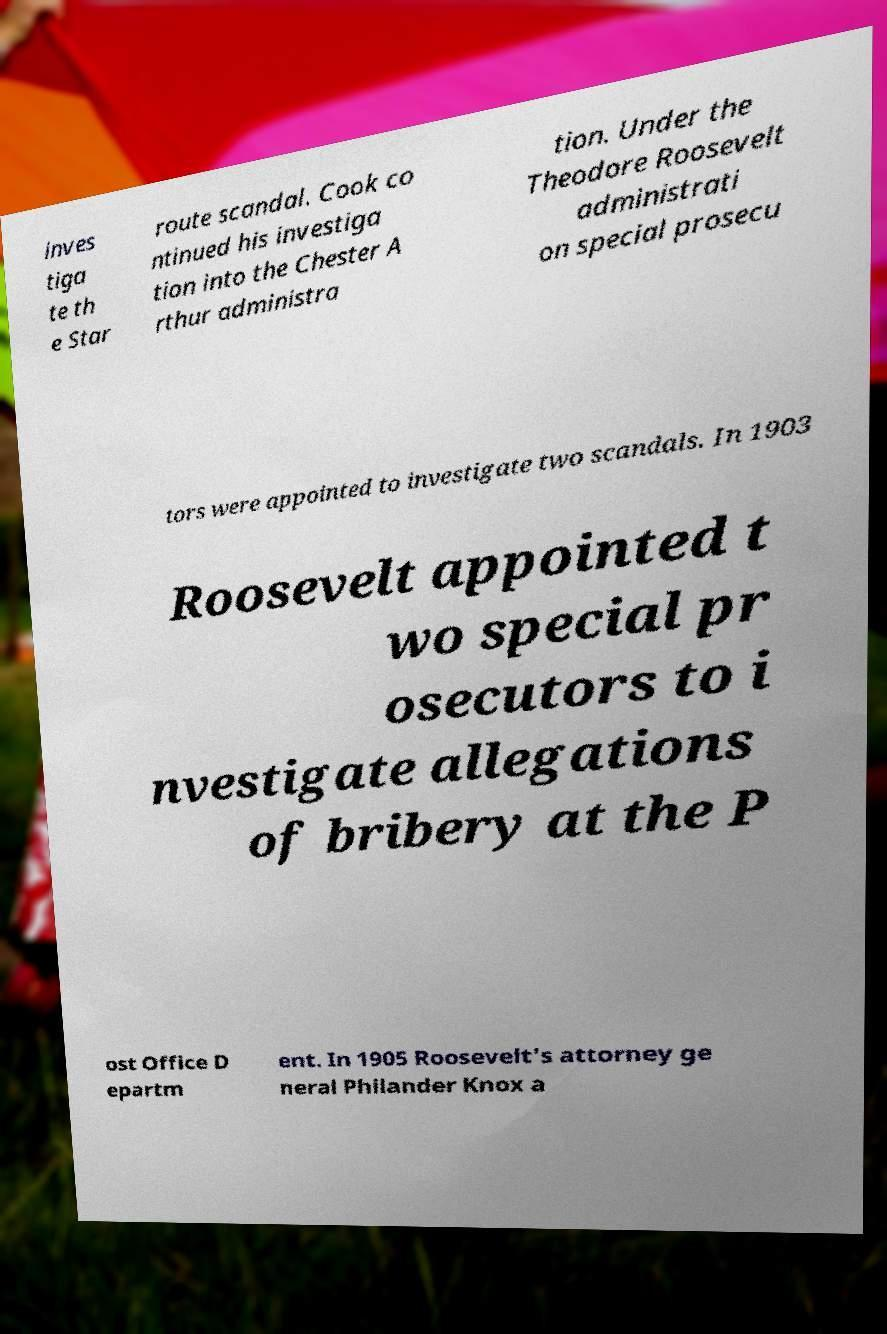Please identify and transcribe the text found in this image. inves tiga te th e Star route scandal. Cook co ntinued his investiga tion into the Chester A rthur administra tion. Under the Theodore Roosevelt administrati on special prosecu tors were appointed to investigate two scandals. In 1903 Roosevelt appointed t wo special pr osecutors to i nvestigate allegations of bribery at the P ost Office D epartm ent. In 1905 Roosevelt's attorney ge neral Philander Knox a 